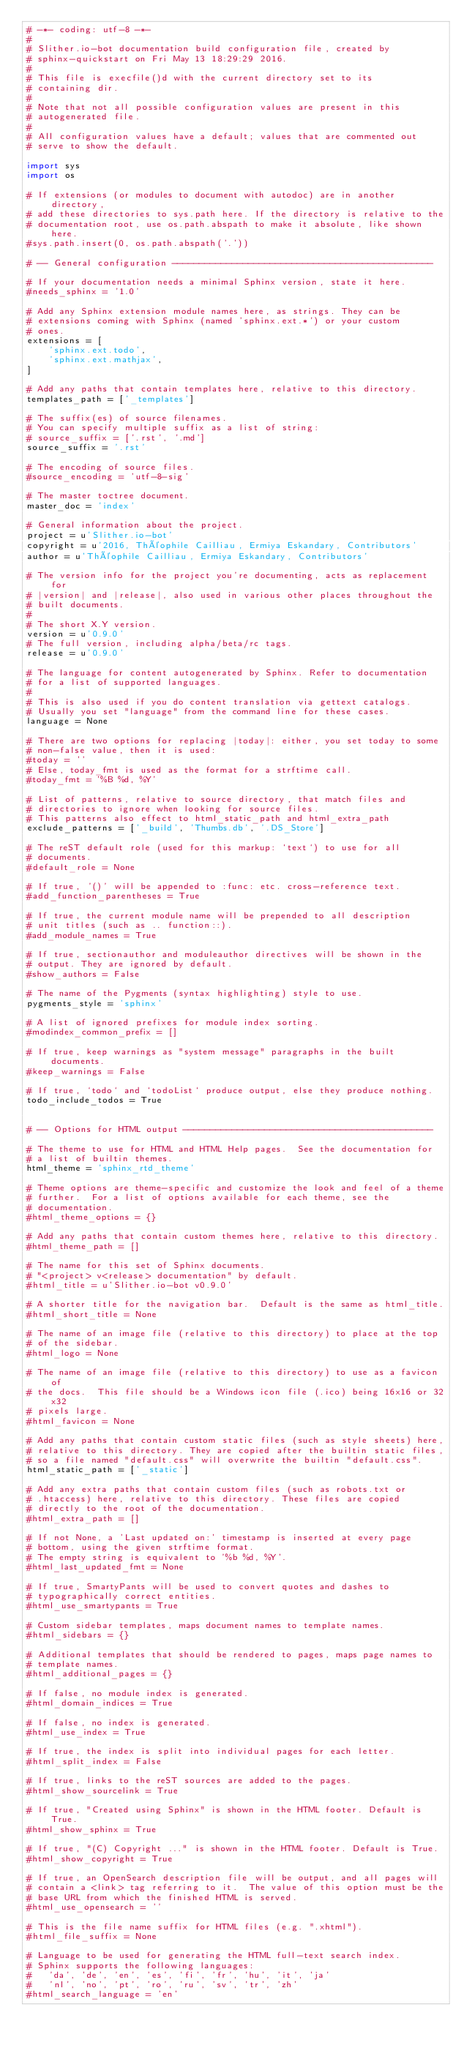Convert code to text. <code><loc_0><loc_0><loc_500><loc_500><_Python_># -*- coding: utf-8 -*-
#
# Slither.io-bot documentation build configuration file, created by
# sphinx-quickstart on Fri May 13 18:29:29 2016.
#
# This file is execfile()d with the current directory set to its
# containing dir.
#
# Note that not all possible configuration values are present in this
# autogenerated file.
#
# All configuration values have a default; values that are commented out
# serve to show the default.

import sys
import os

# If extensions (or modules to document with autodoc) are in another directory,
# add these directories to sys.path here. If the directory is relative to the
# documentation root, use os.path.abspath to make it absolute, like shown here.
#sys.path.insert(0, os.path.abspath('.'))

# -- General configuration ------------------------------------------------

# If your documentation needs a minimal Sphinx version, state it here.
#needs_sphinx = '1.0'

# Add any Sphinx extension module names here, as strings. They can be
# extensions coming with Sphinx (named 'sphinx.ext.*') or your custom
# ones.
extensions = [
    'sphinx.ext.todo',
    'sphinx.ext.mathjax',
]

# Add any paths that contain templates here, relative to this directory.
templates_path = ['_templates']

# The suffix(es) of source filenames.
# You can specify multiple suffix as a list of string:
# source_suffix = ['.rst', '.md']
source_suffix = '.rst'

# The encoding of source files.
#source_encoding = 'utf-8-sig'

# The master toctree document.
master_doc = 'index'

# General information about the project.
project = u'Slither.io-bot'
copyright = u'2016, Théophile Cailliau, Ermiya Eskandary, Contributors'
author = u'Théophile Cailliau, Ermiya Eskandary, Contributors'

# The version info for the project you're documenting, acts as replacement for
# |version| and |release|, also used in various other places throughout the
# built documents.
#
# The short X.Y version.
version = u'0.9.0'
# The full version, including alpha/beta/rc tags.
release = u'0.9.0'

# The language for content autogenerated by Sphinx. Refer to documentation
# for a list of supported languages.
#
# This is also used if you do content translation via gettext catalogs.
# Usually you set "language" from the command line for these cases.
language = None

# There are two options for replacing |today|: either, you set today to some
# non-false value, then it is used:
#today = ''
# Else, today_fmt is used as the format for a strftime call.
#today_fmt = '%B %d, %Y'

# List of patterns, relative to source directory, that match files and
# directories to ignore when looking for source files.
# This patterns also effect to html_static_path and html_extra_path
exclude_patterns = ['_build', 'Thumbs.db', '.DS_Store']

# The reST default role (used for this markup: `text`) to use for all
# documents.
#default_role = None

# If true, '()' will be appended to :func: etc. cross-reference text.
#add_function_parentheses = True

# If true, the current module name will be prepended to all description
# unit titles (such as .. function::).
#add_module_names = True

# If true, sectionauthor and moduleauthor directives will be shown in the
# output. They are ignored by default.
#show_authors = False

# The name of the Pygments (syntax highlighting) style to use.
pygments_style = 'sphinx'

# A list of ignored prefixes for module index sorting.
#modindex_common_prefix = []

# If true, keep warnings as "system message" paragraphs in the built documents.
#keep_warnings = False

# If true, `todo` and `todoList` produce output, else they produce nothing.
todo_include_todos = True


# -- Options for HTML output ----------------------------------------------

# The theme to use for HTML and HTML Help pages.  See the documentation for
# a list of builtin themes.
html_theme = 'sphinx_rtd_theme'

# Theme options are theme-specific and customize the look and feel of a theme
# further.  For a list of options available for each theme, see the
# documentation.
#html_theme_options = {}

# Add any paths that contain custom themes here, relative to this directory.
#html_theme_path = []

# The name for this set of Sphinx documents.
# "<project> v<release> documentation" by default.
#html_title = u'Slither.io-bot v0.9.0'

# A shorter title for the navigation bar.  Default is the same as html_title.
#html_short_title = None

# The name of an image file (relative to this directory) to place at the top
# of the sidebar.
#html_logo = None

# The name of an image file (relative to this directory) to use as a favicon of
# the docs.  This file should be a Windows icon file (.ico) being 16x16 or 32x32
# pixels large.
#html_favicon = None

# Add any paths that contain custom static files (such as style sheets) here,
# relative to this directory. They are copied after the builtin static files,
# so a file named "default.css" will overwrite the builtin "default.css".
html_static_path = ['_static']

# Add any extra paths that contain custom files (such as robots.txt or
# .htaccess) here, relative to this directory. These files are copied
# directly to the root of the documentation.
#html_extra_path = []

# If not None, a 'Last updated on:' timestamp is inserted at every page
# bottom, using the given strftime format.
# The empty string is equivalent to '%b %d, %Y'.
#html_last_updated_fmt = None

# If true, SmartyPants will be used to convert quotes and dashes to
# typographically correct entities.
#html_use_smartypants = True

# Custom sidebar templates, maps document names to template names.
#html_sidebars = {}

# Additional templates that should be rendered to pages, maps page names to
# template names.
#html_additional_pages = {}

# If false, no module index is generated.
#html_domain_indices = True

# If false, no index is generated.
#html_use_index = True

# If true, the index is split into individual pages for each letter.
#html_split_index = False

# If true, links to the reST sources are added to the pages.
#html_show_sourcelink = True

# If true, "Created using Sphinx" is shown in the HTML footer. Default is True.
#html_show_sphinx = True

# If true, "(C) Copyright ..." is shown in the HTML footer. Default is True.
#html_show_copyright = True

# If true, an OpenSearch description file will be output, and all pages will
# contain a <link> tag referring to it.  The value of this option must be the
# base URL from which the finished HTML is served.
#html_use_opensearch = ''

# This is the file name suffix for HTML files (e.g. ".xhtml").
#html_file_suffix = None

# Language to be used for generating the HTML full-text search index.
# Sphinx supports the following languages:
#   'da', 'de', 'en', 'es', 'fi', 'fr', 'hu', 'it', 'ja'
#   'nl', 'no', 'pt', 'ro', 'ru', 'sv', 'tr', 'zh'
#html_search_language = 'en'
</code> 